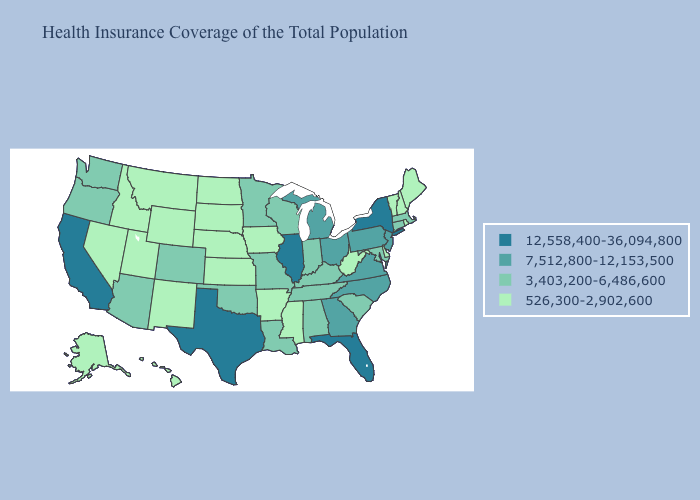Is the legend a continuous bar?
Answer briefly. No. Name the states that have a value in the range 526,300-2,902,600?
Answer briefly. Alaska, Arkansas, Delaware, Hawaii, Idaho, Iowa, Kansas, Maine, Mississippi, Montana, Nebraska, Nevada, New Hampshire, New Mexico, North Dakota, Rhode Island, South Dakota, Utah, Vermont, West Virginia, Wyoming. What is the lowest value in states that border Louisiana?
Be succinct. 526,300-2,902,600. Does Delaware have a higher value than North Dakota?
Short answer required. No. What is the lowest value in states that border Missouri?
Write a very short answer. 526,300-2,902,600. Does the map have missing data?
Write a very short answer. No. Does Illinois have the highest value in the MidWest?
Keep it brief. Yes. Which states hav the highest value in the MidWest?
Keep it brief. Illinois. Does Oregon have a lower value than South Carolina?
Short answer required. No. What is the value of Arkansas?
Be succinct. 526,300-2,902,600. What is the value of Texas?
Answer briefly. 12,558,400-36,094,800. Among the states that border Wisconsin , does Illinois have the highest value?
Concise answer only. Yes. What is the lowest value in states that border Michigan?
Answer briefly. 3,403,200-6,486,600. What is the value of West Virginia?
Concise answer only. 526,300-2,902,600. What is the value of Missouri?
Be succinct. 3,403,200-6,486,600. 